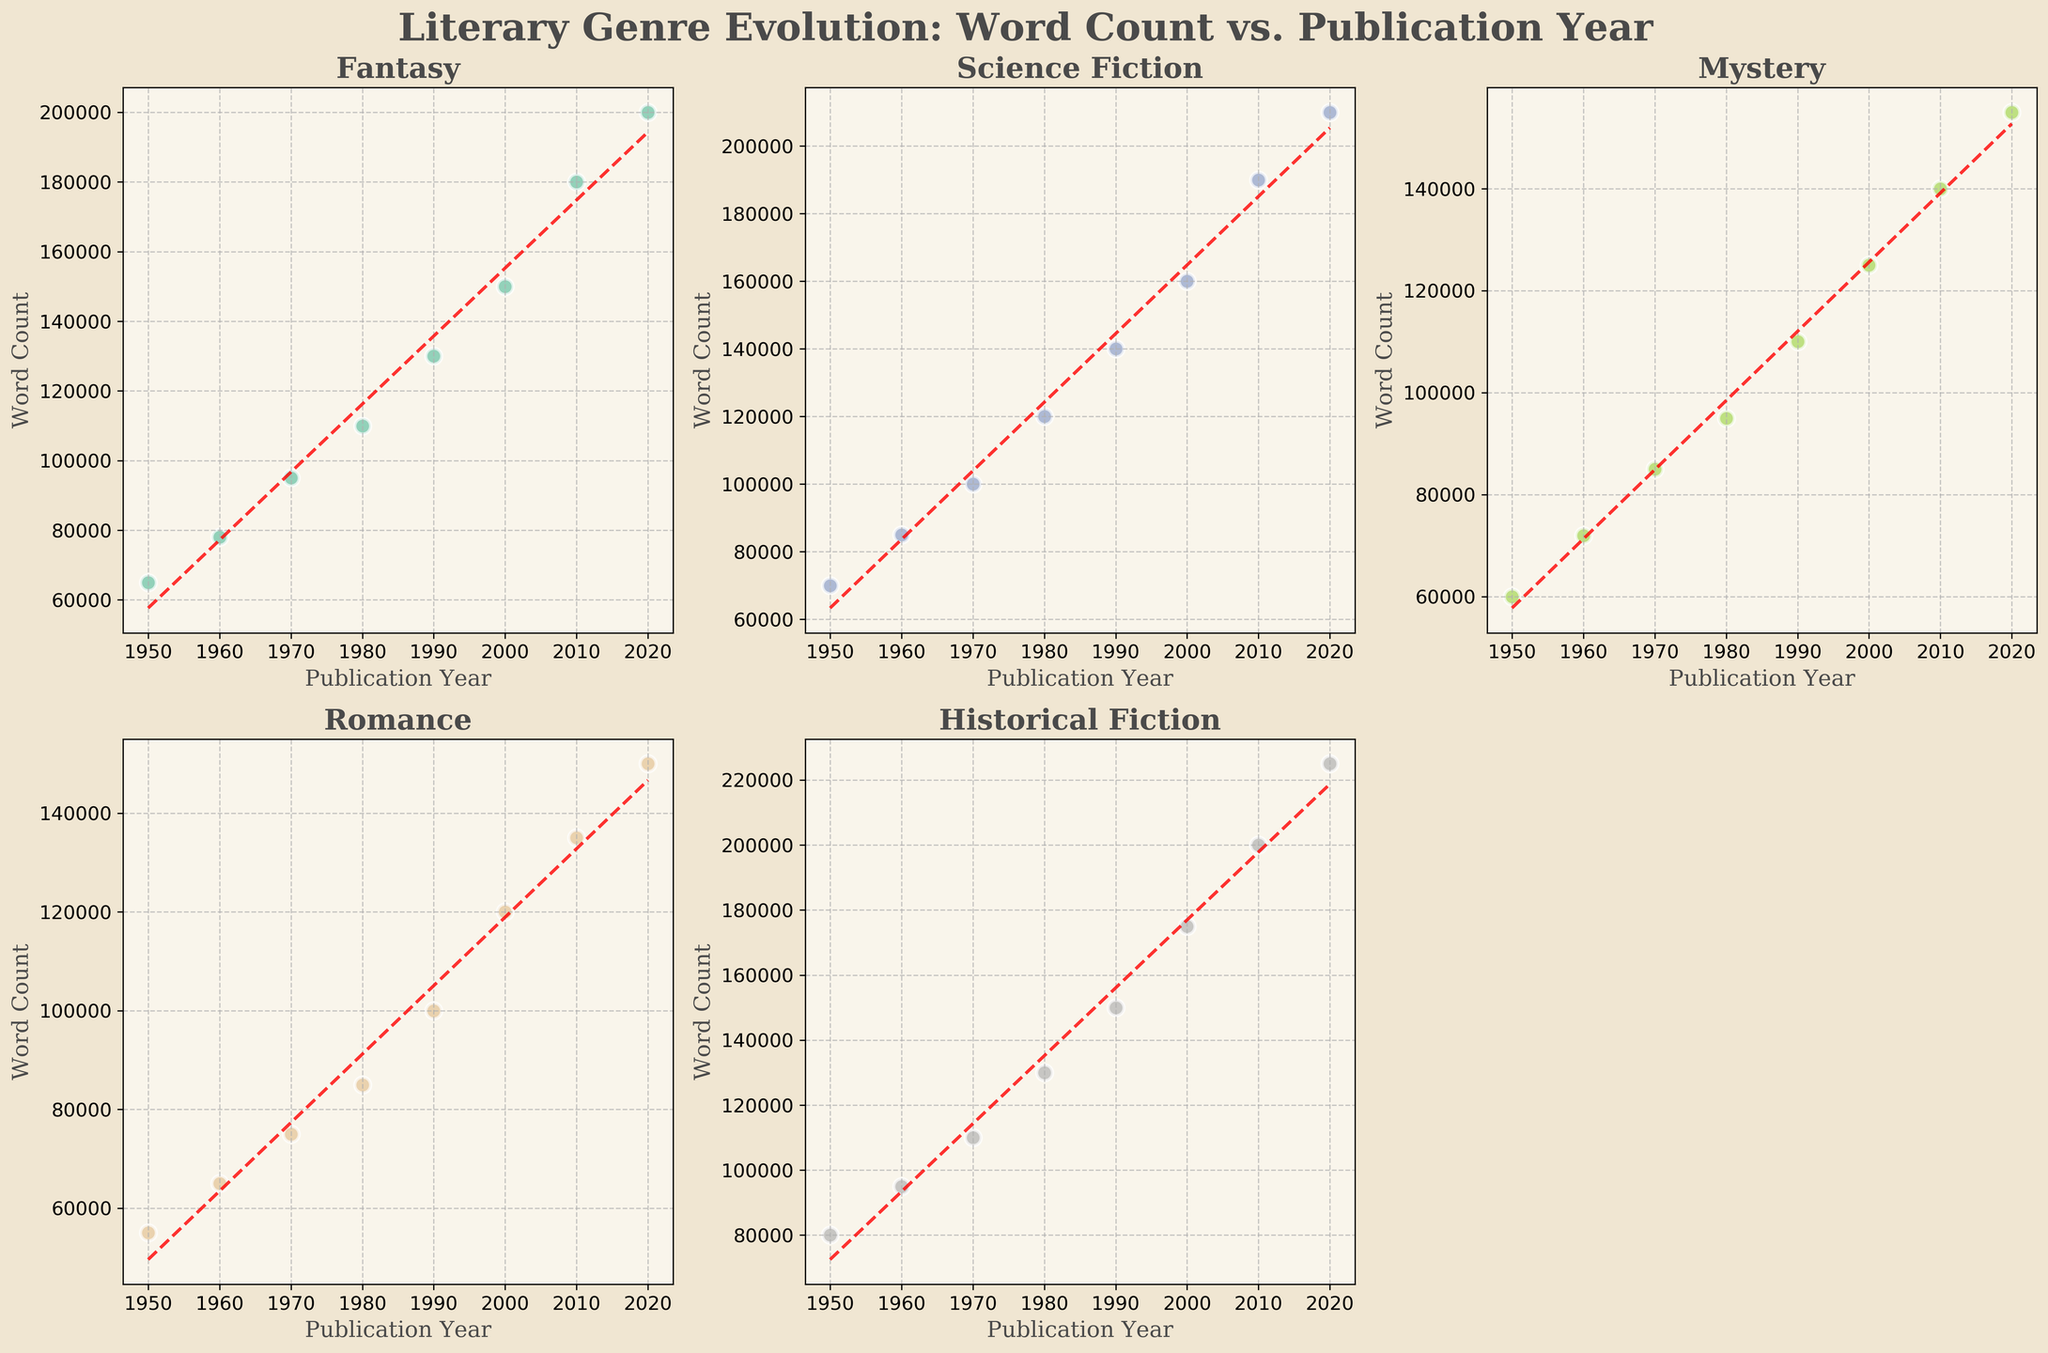What genre had the highest word count in 2020? By looking at the scatter plots for each genre, we see that the genre with the highest word count in 2020 is 'Historical Fiction', as indicated by the highest point on the graph in the year 2020.
Answer: Historical Fiction Which genre consistently had lower word counts than 'Fantasy' across all years? To determine this, we compare the scatter plot of 'Fantasy' with other genres. 'Romance' consistently had lower word counts than 'Fantasy' in every published year.
Answer: Romance Is there any genre where the word count decreased over time? By analyzing the trend lines in the plots, we can see that all trends indicate an increase in word count over time. Therefore, no genre displayed a decreasing word count trend.
Answer: No How does the word count growth rate of 'Science Fiction' compare to 'Mystery'? We observe the trend lines in the scatter plots for a visual comparison. 'Science Fiction' has a steeper trend line than 'Mystery', indicating a higher growth rate in word count over time.
Answer: Higher Which genre shows the steepest increase in word count over the years? By evaluating the trend lines, 'Historical Fiction' shows the steepest increase in word count, as indicated by the most sharply rising line.
Answer: Historical Fiction What is the average word count of books published in 2000 for all genres? Sum the word counts of all genres for the year 2000 (150000 + 160000 + 125000 + 120000 + 175000) and divide by the number of genres (5): (150000 + 160000 + 125000 + 120000 + 175000) / 5 = 730000 / 5 = 146000.
Answer: 146000 What is the difference in word count for 'Romance' books published in 1970 and 2000? Subtract the word count for 'Romance' in 1970 from that in 2000: 120000 - 75000 = 45000.
Answer: 45000 Which genre's word count grew the least from 1950 to 2020? By comparing the first and last points in the plots, 'Mystery' had the smallest growth (155000 in 2020 - 60000 in 1950 = 95000) in word count over the years.
Answer: Mystery How does the publication year affect the word count for 'Fantasy' compared with 'Romance'? Both 'Fantasy' and 'Romance' show an increase in word count over the years. However, 'Fantasy' has a sharper increase than 'Romance', indicating a stronger relationship between publication year and word count for 'Fantasy'.
Answer: Fantasy shows a stronger relationship Which genre had the lowest word count in the earliest year in the data set? Observing the scatter plots, 'Romance' has the lowest word count in the year 1950, shown by the lowest point on the x-axis.
Answer: Romance 